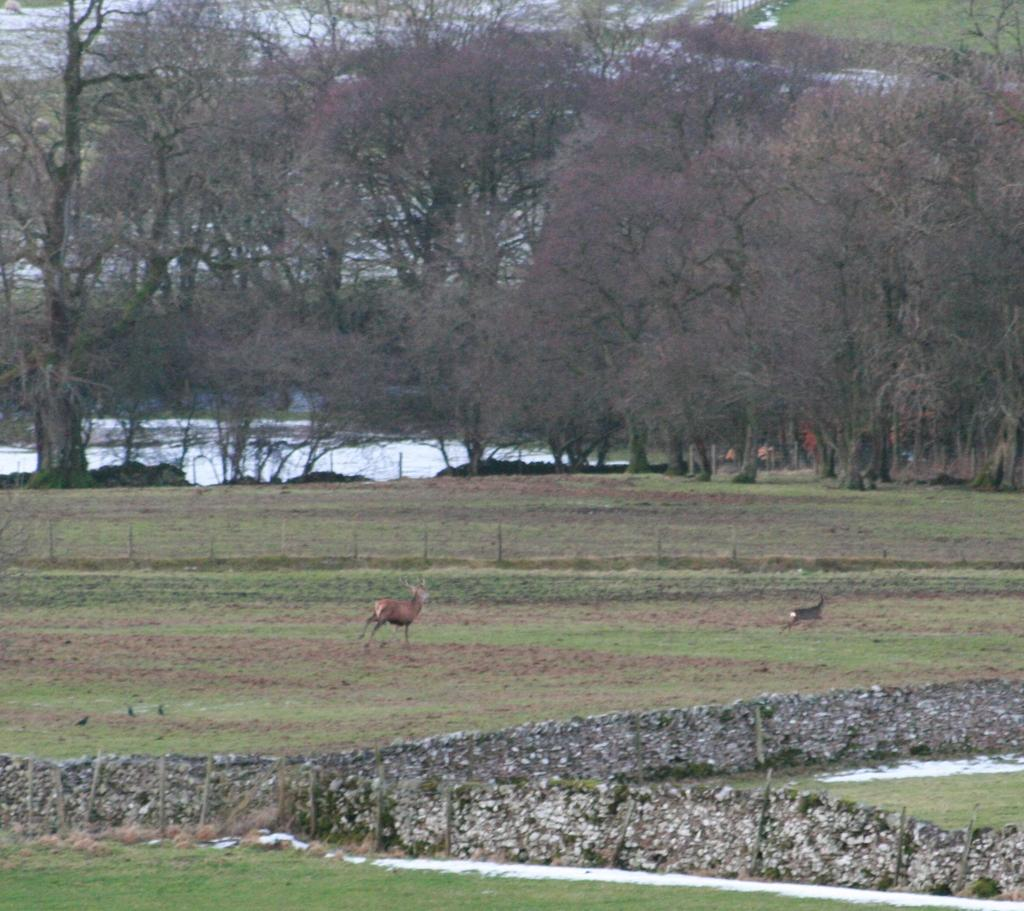What is located in the center of the image? There are animals in the center of the image. What type of terrain is visible at the bottom of the image? There is grass and small stones at the bottom of the image. What can be seen in the background of the image? There are trees in the background of the image. What type of scissors can be seen cutting the grass in the image? There are no scissors present in the image; the grass is not being cut. How does the bubble affect the animals in the image? There is no bubble present in the image, so it does not affect the animals. 